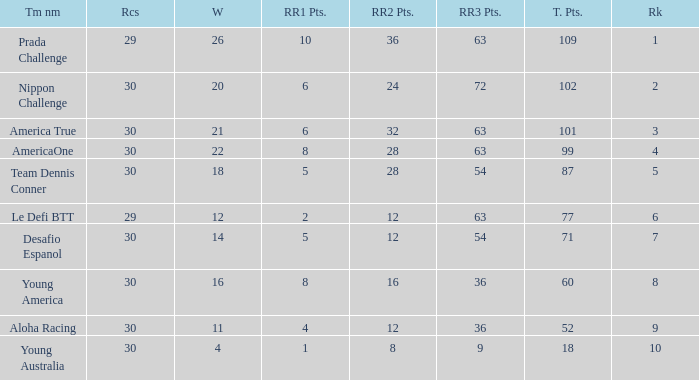Name the races for the prada challenge 29.0. 